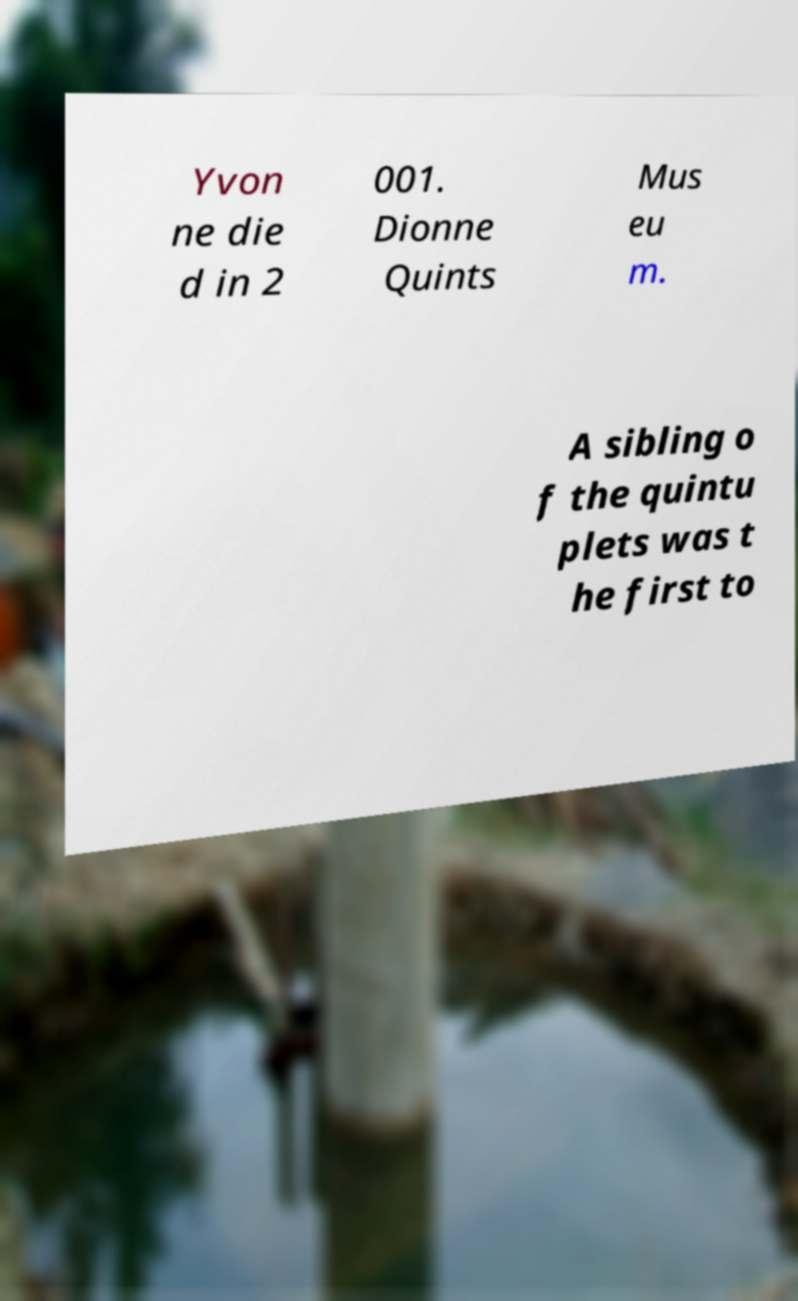Please identify and transcribe the text found in this image. Yvon ne die d in 2 001. Dionne Quints Mus eu m. A sibling o f the quintu plets was t he first to 